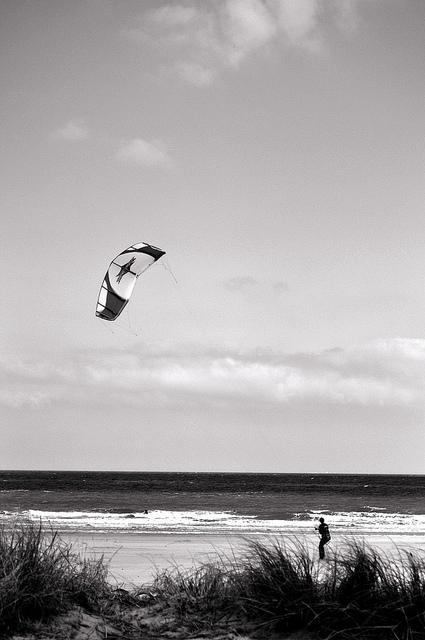Is someone holding the kite on a string?
Short answer required. Yes. What is the person in the middle doing?
Concise answer only. Flying kite. What sport is being participated in?
Be succinct. Kite flying. What is the person flying in the sky?
Keep it brief. Kite. Is the water calm?
Quick response, please. No. 